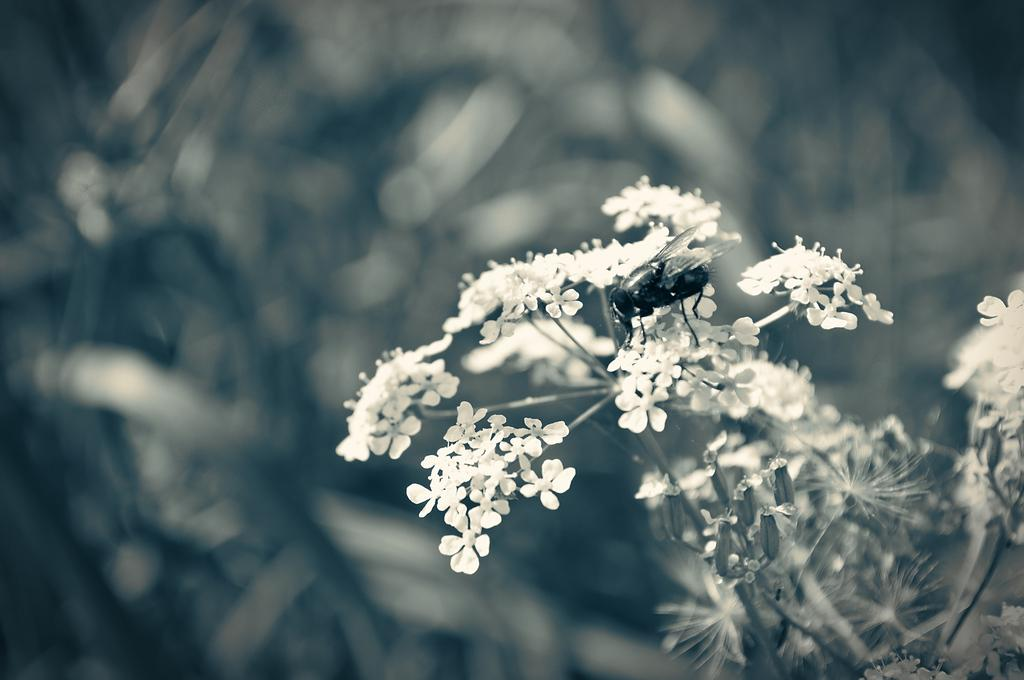What type of creature is present in the image? There is an insect with wings in the image. What is the insect doing in the image? The insect is on flowers. How would you describe the background of the image? The background of the image is blurry. What is the measurement of the power source used by the insect in the image? There is no power source mentioned in the image, and the insect does not have a measurable size or power source. 